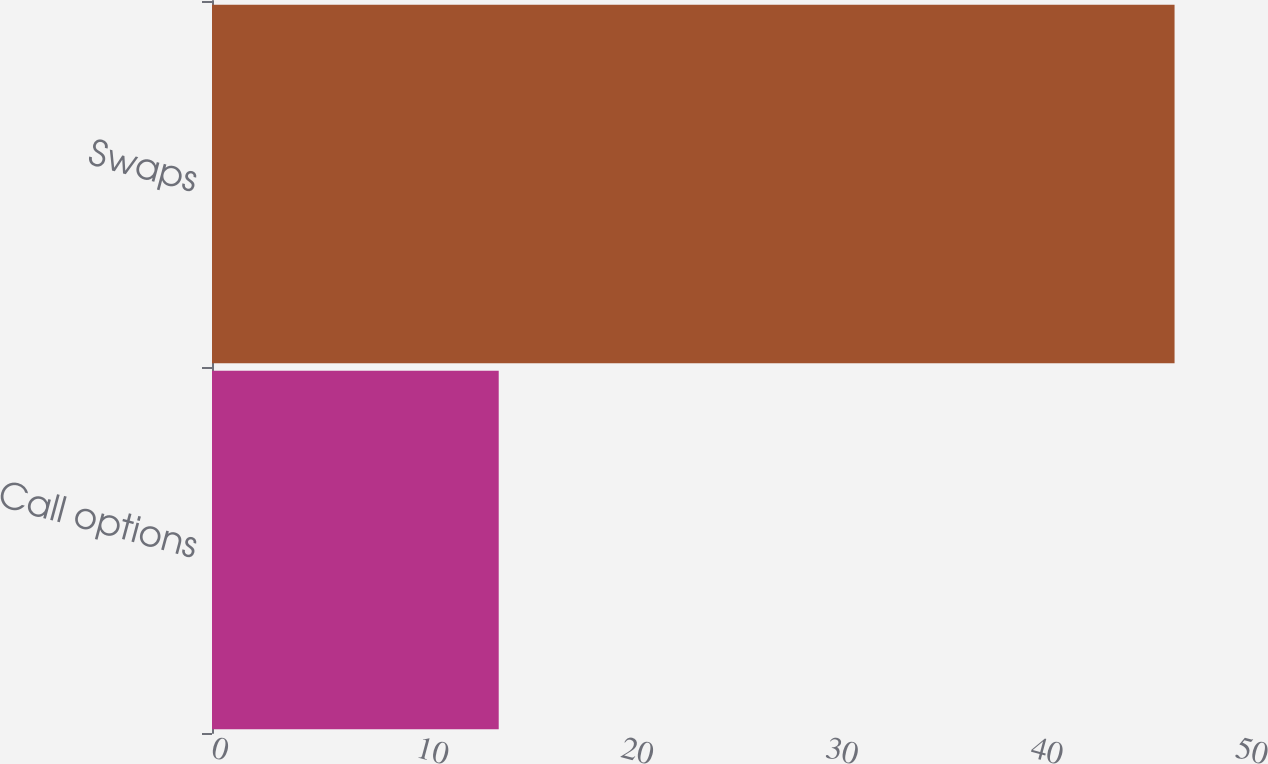Convert chart. <chart><loc_0><loc_0><loc_500><loc_500><bar_chart><fcel>Call options<fcel>Swaps<nl><fcel>14<fcel>47<nl></chart> 